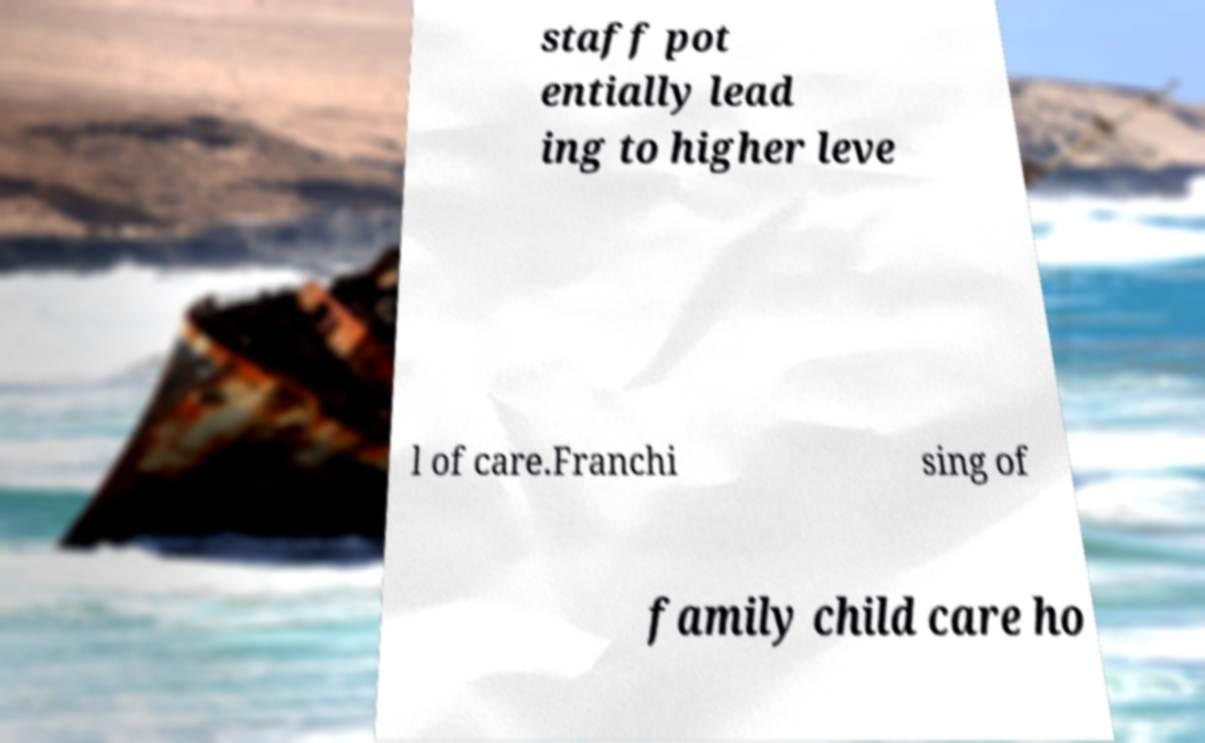Please read and relay the text visible in this image. What does it say? staff pot entially lead ing to higher leve l of care.Franchi sing of family child care ho 